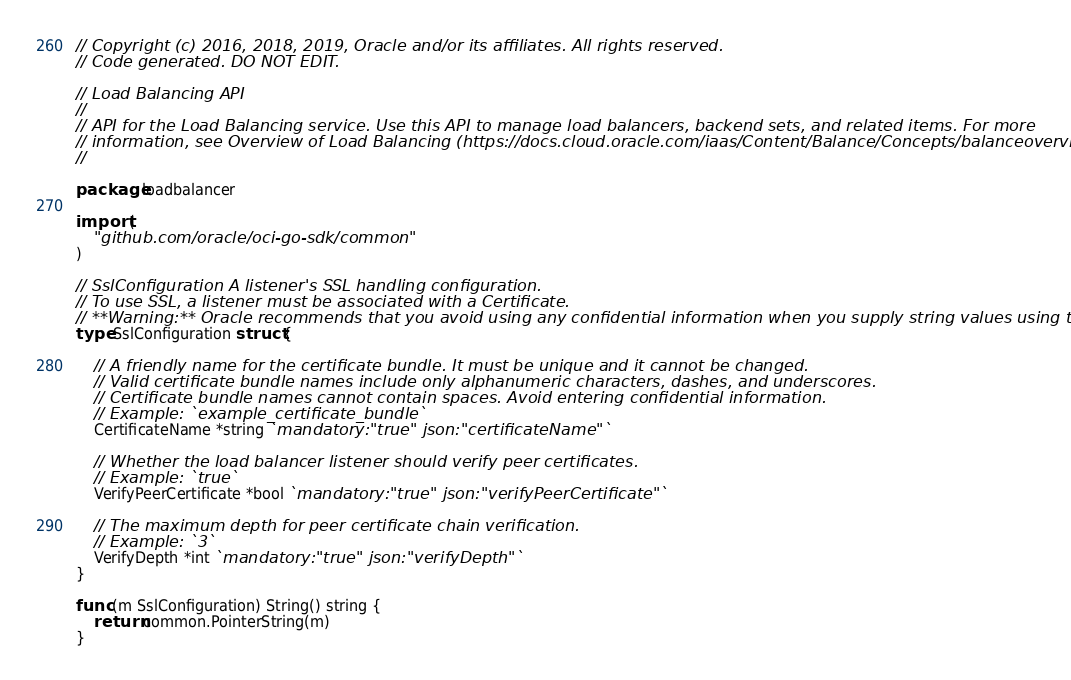<code> <loc_0><loc_0><loc_500><loc_500><_Go_>// Copyright (c) 2016, 2018, 2019, Oracle and/or its affiliates. All rights reserved.
// Code generated. DO NOT EDIT.

// Load Balancing API
//
// API for the Load Balancing service. Use this API to manage load balancers, backend sets, and related items. For more
// information, see Overview of Load Balancing (https://docs.cloud.oracle.com/iaas/Content/Balance/Concepts/balanceoverview.htm).
//

package loadbalancer

import (
	"github.com/oracle/oci-go-sdk/common"
)

// SslConfiguration A listener's SSL handling configuration.
// To use SSL, a listener must be associated with a Certificate.
// **Warning:** Oracle recommends that you avoid using any confidential information when you supply string values using the API.
type SslConfiguration struct {

	// A friendly name for the certificate bundle. It must be unique and it cannot be changed.
	// Valid certificate bundle names include only alphanumeric characters, dashes, and underscores.
	// Certificate bundle names cannot contain spaces. Avoid entering confidential information.
	// Example: `example_certificate_bundle`
	CertificateName *string `mandatory:"true" json:"certificateName"`

	// Whether the load balancer listener should verify peer certificates.
	// Example: `true`
	VerifyPeerCertificate *bool `mandatory:"true" json:"verifyPeerCertificate"`

	// The maximum depth for peer certificate chain verification.
	// Example: `3`
	VerifyDepth *int `mandatory:"true" json:"verifyDepth"`
}

func (m SslConfiguration) String() string {
	return common.PointerString(m)
}
</code> 